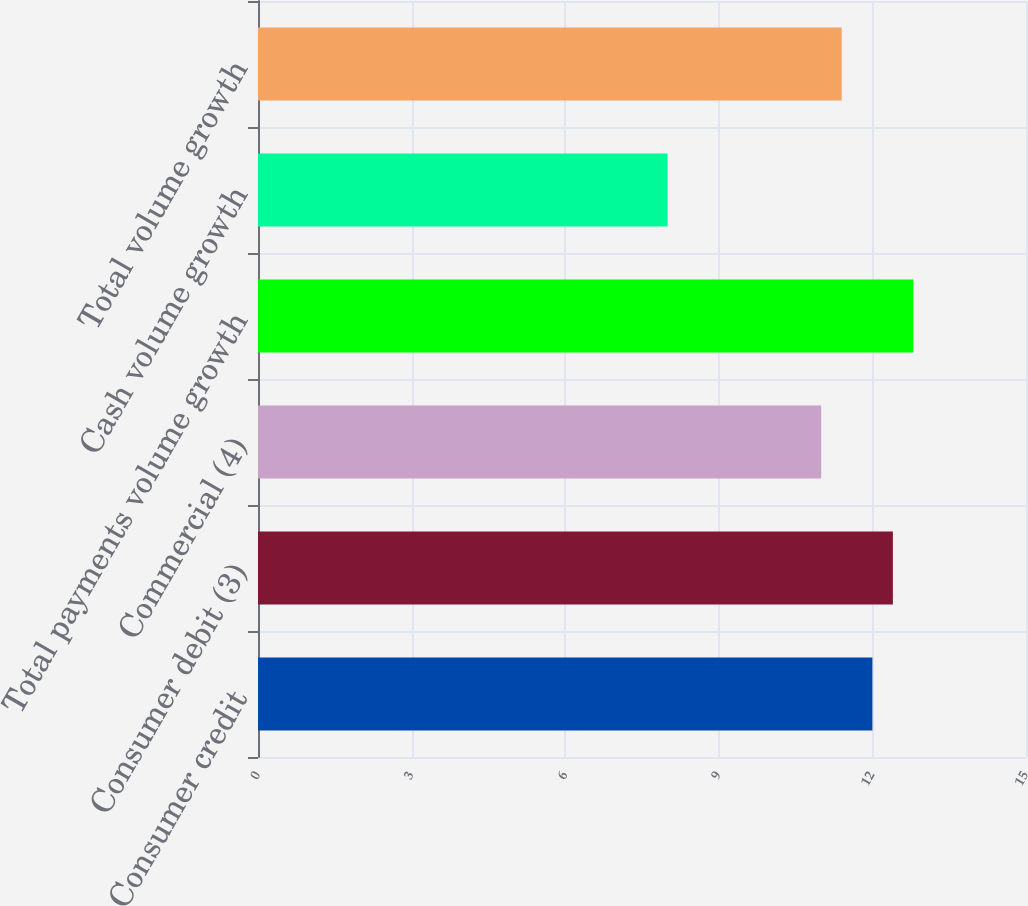Convert chart. <chart><loc_0><loc_0><loc_500><loc_500><bar_chart><fcel>Consumer credit<fcel>Consumer debit (3)<fcel>Commercial (4)<fcel>Total payments volume growth<fcel>Cash volume growth<fcel>Total volume growth<nl><fcel>12<fcel>12.4<fcel>11<fcel>12.8<fcel>8<fcel>11.4<nl></chart> 